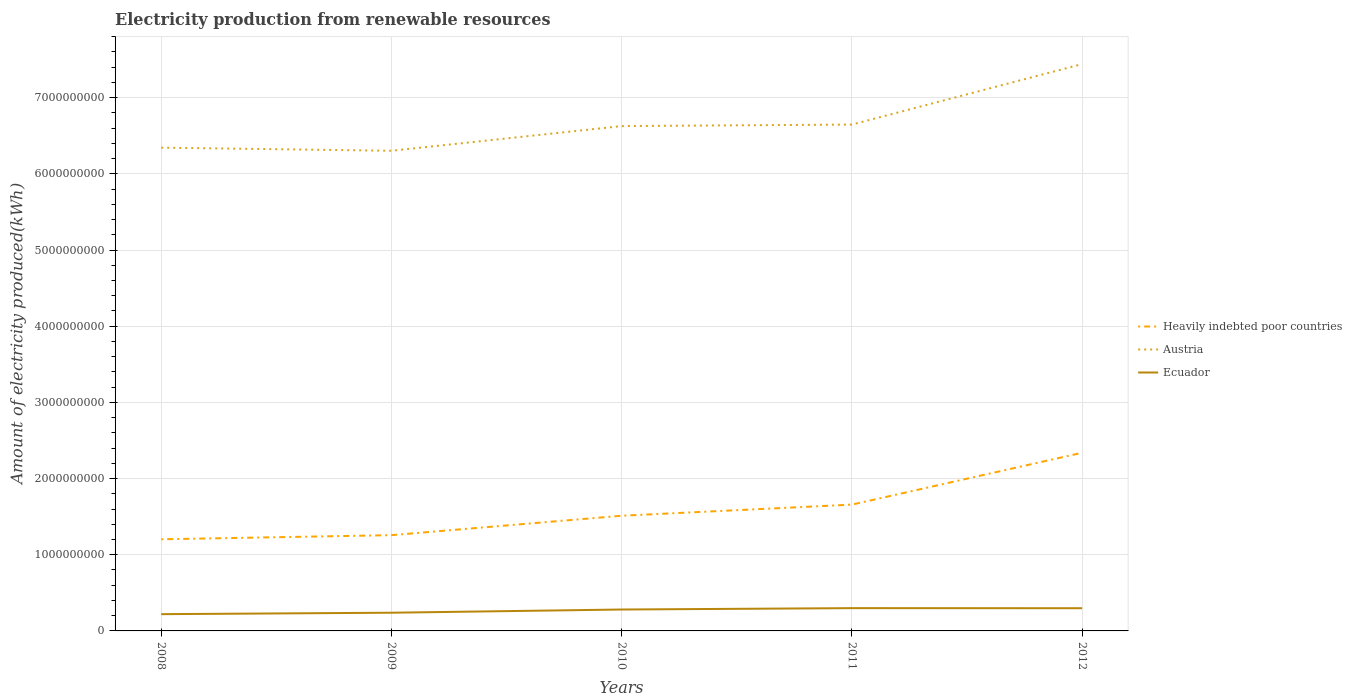How many different coloured lines are there?
Your answer should be compact. 3. Does the line corresponding to Heavily indebted poor countries intersect with the line corresponding to Austria?
Make the answer very short. No. Is the number of lines equal to the number of legend labels?
Your response must be concise. Yes. Across all years, what is the maximum amount of electricity produced in Ecuador?
Your answer should be very brief. 2.20e+08. What is the total amount of electricity produced in Heavily indebted poor countries in the graph?
Give a very brief answer. -5.40e+07. What is the difference between the highest and the second highest amount of electricity produced in Austria?
Provide a succinct answer. 1.14e+09. Is the amount of electricity produced in Ecuador strictly greater than the amount of electricity produced in Austria over the years?
Your answer should be compact. Yes. How many lines are there?
Your answer should be very brief. 3. What is the difference between two consecutive major ticks on the Y-axis?
Your response must be concise. 1.00e+09. Does the graph contain grids?
Make the answer very short. Yes. Where does the legend appear in the graph?
Offer a terse response. Center right. How many legend labels are there?
Give a very brief answer. 3. How are the legend labels stacked?
Give a very brief answer. Vertical. What is the title of the graph?
Keep it short and to the point. Electricity production from renewable resources. What is the label or title of the Y-axis?
Your answer should be very brief. Amount of electricity produced(kWh). What is the Amount of electricity produced(kWh) of Heavily indebted poor countries in 2008?
Your answer should be very brief. 1.20e+09. What is the Amount of electricity produced(kWh) in Austria in 2008?
Ensure brevity in your answer.  6.34e+09. What is the Amount of electricity produced(kWh) in Ecuador in 2008?
Your answer should be compact. 2.20e+08. What is the Amount of electricity produced(kWh) of Heavily indebted poor countries in 2009?
Keep it short and to the point. 1.26e+09. What is the Amount of electricity produced(kWh) of Austria in 2009?
Make the answer very short. 6.30e+09. What is the Amount of electricity produced(kWh) of Ecuador in 2009?
Your answer should be compact. 2.39e+08. What is the Amount of electricity produced(kWh) in Heavily indebted poor countries in 2010?
Ensure brevity in your answer.  1.51e+09. What is the Amount of electricity produced(kWh) of Austria in 2010?
Give a very brief answer. 6.63e+09. What is the Amount of electricity produced(kWh) of Ecuador in 2010?
Keep it short and to the point. 2.81e+08. What is the Amount of electricity produced(kWh) of Heavily indebted poor countries in 2011?
Make the answer very short. 1.66e+09. What is the Amount of electricity produced(kWh) of Austria in 2011?
Your response must be concise. 6.65e+09. What is the Amount of electricity produced(kWh) of Ecuador in 2011?
Your answer should be very brief. 2.99e+08. What is the Amount of electricity produced(kWh) of Heavily indebted poor countries in 2012?
Keep it short and to the point. 2.34e+09. What is the Amount of electricity produced(kWh) in Austria in 2012?
Provide a short and direct response. 7.44e+09. What is the Amount of electricity produced(kWh) in Ecuador in 2012?
Offer a very short reply. 2.98e+08. Across all years, what is the maximum Amount of electricity produced(kWh) of Heavily indebted poor countries?
Offer a very short reply. 2.34e+09. Across all years, what is the maximum Amount of electricity produced(kWh) in Austria?
Provide a short and direct response. 7.44e+09. Across all years, what is the maximum Amount of electricity produced(kWh) in Ecuador?
Your answer should be compact. 2.99e+08. Across all years, what is the minimum Amount of electricity produced(kWh) in Heavily indebted poor countries?
Make the answer very short. 1.20e+09. Across all years, what is the minimum Amount of electricity produced(kWh) in Austria?
Your response must be concise. 6.30e+09. Across all years, what is the minimum Amount of electricity produced(kWh) in Ecuador?
Your answer should be compact. 2.20e+08. What is the total Amount of electricity produced(kWh) in Heavily indebted poor countries in the graph?
Your answer should be compact. 7.97e+09. What is the total Amount of electricity produced(kWh) in Austria in the graph?
Provide a succinct answer. 3.34e+1. What is the total Amount of electricity produced(kWh) in Ecuador in the graph?
Your answer should be compact. 1.34e+09. What is the difference between the Amount of electricity produced(kWh) in Heavily indebted poor countries in 2008 and that in 2009?
Ensure brevity in your answer.  -5.40e+07. What is the difference between the Amount of electricity produced(kWh) in Austria in 2008 and that in 2009?
Your answer should be compact. 4.10e+07. What is the difference between the Amount of electricity produced(kWh) of Ecuador in 2008 and that in 2009?
Keep it short and to the point. -1.90e+07. What is the difference between the Amount of electricity produced(kWh) of Heavily indebted poor countries in 2008 and that in 2010?
Provide a succinct answer. -3.09e+08. What is the difference between the Amount of electricity produced(kWh) in Austria in 2008 and that in 2010?
Offer a terse response. -2.83e+08. What is the difference between the Amount of electricity produced(kWh) in Ecuador in 2008 and that in 2010?
Provide a succinct answer. -6.10e+07. What is the difference between the Amount of electricity produced(kWh) in Heavily indebted poor countries in 2008 and that in 2011?
Offer a very short reply. -4.55e+08. What is the difference between the Amount of electricity produced(kWh) in Austria in 2008 and that in 2011?
Provide a short and direct response. -3.03e+08. What is the difference between the Amount of electricity produced(kWh) in Ecuador in 2008 and that in 2011?
Provide a short and direct response. -7.90e+07. What is the difference between the Amount of electricity produced(kWh) of Heavily indebted poor countries in 2008 and that in 2012?
Keep it short and to the point. -1.14e+09. What is the difference between the Amount of electricity produced(kWh) of Austria in 2008 and that in 2012?
Your answer should be compact. -1.10e+09. What is the difference between the Amount of electricity produced(kWh) in Ecuador in 2008 and that in 2012?
Offer a very short reply. -7.80e+07. What is the difference between the Amount of electricity produced(kWh) of Heavily indebted poor countries in 2009 and that in 2010?
Offer a very short reply. -2.55e+08. What is the difference between the Amount of electricity produced(kWh) of Austria in 2009 and that in 2010?
Your answer should be very brief. -3.24e+08. What is the difference between the Amount of electricity produced(kWh) of Ecuador in 2009 and that in 2010?
Your answer should be compact. -4.20e+07. What is the difference between the Amount of electricity produced(kWh) of Heavily indebted poor countries in 2009 and that in 2011?
Make the answer very short. -4.01e+08. What is the difference between the Amount of electricity produced(kWh) of Austria in 2009 and that in 2011?
Offer a very short reply. -3.44e+08. What is the difference between the Amount of electricity produced(kWh) of Ecuador in 2009 and that in 2011?
Give a very brief answer. -6.00e+07. What is the difference between the Amount of electricity produced(kWh) in Heavily indebted poor countries in 2009 and that in 2012?
Offer a very short reply. -1.08e+09. What is the difference between the Amount of electricity produced(kWh) in Austria in 2009 and that in 2012?
Keep it short and to the point. -1.14e+09. What is the difference between the Amount of electricity produced(kWh) in Ecuador in 2009 and that in 2012?
Give a very brief answer. -5.90e+07. What is the difference between the Amount of electricity produced(kWh) in Heavily indebted poor countries in 2010 and that in 2011?
Offer a terse response. -1.46e+08. What is the difference between the Amount of electricity produced(kWh) of Austria in 2010 and that in 2011?
Provide a short and direct response. -2.00e+07. What is the difference between the Amount of electricity produced(kWh) in Ecuador in 2010 and that in 2011?
Provide a succinct answer. -1.80e+07. What is the difference between the Amount of electricity produced(kWh) in Heavily indebted poor countries in 2010 and that in 2012?
Provide a succinct answer. -8.27e+08. What is the difference between the Amount of electricity produced(kWh) in Austria in 2010 and that in 2012?
Make the answer very short. -8.14e+08. What is the difference between the Amount of electricity produced(kWh) of Ecuador in 2010 and that in 2012?
Your answer should be compact. -1.70e+07. What is the difference between the Amount of electricity produced(kWh) of Heavily indebted poor countries in 2011 and that in 2012?
Provide a short and direct response. -6.81e+08. What is the difference between the Amount of electricity produced(kWh) in Austria in 2011 and that in 2012?
Your answer should be compact. -7.94e+08. What is the difference between the Amount of electricity produced(kWh) in Ecuador in 2011 and that in 2012?
Offer a very short reply. 1.00e+06. What is the difference between the Amount of electricity produced(kWh) in Heavily indebted poor countries in 2008 and the Amount of electricity produced(kWh) in Austria in 2009?
Provide a short and direct response. -5.10e+09. What is the difference between the Amount of electricity produced(kWh) in Heavily indebted poor countries in 2008 and the Amount of electricity produced(kWh) in Ecuador in 2009?
Keep it short and to the point. 9.64e+08. What is the difference between the Amount of electricity produced(kWh) in Austria in 2008 and the Amount of electricity produced(kWh) in Ecuador in 2009?
Make the answer very short. 6.10e+09. What is the difference between the Amount of electricity produced(kWh) in Heavily indebted poor countries in 2008 and the Amount of electricity produced(kWh) in Austria in 2010?
Give a very brief answer. -5.42e+09. What is the difference between the Amount of electricity produced(kWh) of Heavily indebted poor countries in 2008 and the Amount of electricity produced(kWh) of Ecuador in 2010?
Your answer should be compact. 9.22e+08. What is the difference between the Amount of electricity produced(kWh) of Austria in 2008 and the Amount of electricity produced(kWh) of Ecuador in 2010?
Keep it short and to the point. 6.06e+09. What is the difference between the Amount of electricity produced(kWh) of Heavily indebted poor countries in 2008 and the Amount of electricity produced(kWh) of Austria in 2011?
Provide a short and direct response. -5.44e+09. What is the difference between the Amount of electricity produced(kWh) of Heavily indebted poor countries in 2008 and the Amount of electricity produced(kWh) of Ecuador in 2011?
Offer a terse response. 9.04e+08. What is the difference between the Amount of electricity produced(kWh) of Austria in 2008 and the Amount of electricity produced(kWh) of Ecuador in 2011?
Provide a succinct answer. 6.04e+09. What is the difference between the Amount of electricity produced(kWh) in Heavily indebted poor countries in 2008 and the Amount of electricity produced(kWh) in Austria in 2012?
Ensure brevity in your answer.  -6.24e+09. What is the difference between the Amount of electricity produced(kWh) of Heavily indebted poor countries in 2008 and the Amount of electricity produced(kWh) of Ecuador in 2012?
Your answer should be very brief. 9.05e+08. What is the difference between the Amount of electricity produced(kWh) of Austria in 2008 and the Amount of electricity produced(kWh) of Ecuador in 2012?
Your response must be concise. 6.05e+09. What is the difference between the Amount of electricity produced(kWh) of Heavily indebted poor countries in 2009 and the Amount of electricity produced(kWh) of Austria in 2010?
Your answer should be compact. -5.37e+09. What is the difference between the Amount of electricity produced(kWh) of Heavily indebted poor countries in 2009 and the Amount of electricity produced(kWh) of Ecuador in 2010?
Ensure brevity in your answer.  9.76e+08. What is the difference between the Amount of electricity produced(kWh) in Austria in 2009 and the Amount of electricity produced(kWh) in Ecuador in 2010?
Your answer should be very brief. 6.02e+09. What is the difference between the Amount of electricity produced(kWh) of Heavily indebted poor countries in 2009 and the Amount of electricity produced(kWh) of Austria in 2011?
Offer a terse response. -5.39e+09. What is the difference between the Amount of electricity produced(kWh) in Heavily indebted poor countries in 2009 and the Amount of electricity produced(kWh) in Ecuador in 2011?
Make the answer very short. 9.58e+08. What is the difference between the Amount of electricity produced(kWh) of Austria in 2009 and the Amount of electricity produced(kWh) of Ecuador in 2011?
Your answer should be compact. 6.00e+09. What is the difference between the Amount of electricity produced(kWh) of Heavily indebted poor countries in 2009 and the Amount of electricity produced(kWh) of Austria in 2012?
Provide a short and direct response. -6.18e+09. What is the difference between the Amount of electricity produced(kWh) in Heavily indebted poor countries in 2009 and the Amount of electricity produced(kWh) in Ecuador in 2012?
Offer a very short reply. 9.59e+08. What is the difference between the Amount of electricity produced(kWh) of Austria in 2009 and the Amount of electricity produced(kWh) of Ecuador in 2012?
Provide a short and direct response. 6.00e+09. What is the difference between the Amount of electricity produced(kWh) of Heavily indebted poor countries in 2010 and the Amount of electricity produced(kWh) of Austria in 2011?
Give a very brief answer. -5.14e+09. What is the difference between the Amount of electricity produced(kWh) of Heavily indebted poor countries in 2010 and the Amount of electricity produced(kWh) of Ecuador in 2011?
Your answer should be very brief. 1.21e+09. What is the difference between the Amount of electricity produced(kWh) of Austria in 2010 and the Amount of electricity produced(kWh) of Ecuador in 2011?
Ensure brevity in your answer.  6.33e+09. What is the difference between the Amount of electricity produced(kWh) of Heavily indebted poor countries in 2010 and the Amount of electricity produced(kWh) of Austria in 2012?
Your answer should be very brief. -5.93e+09. What is the difference between the Amount of electricity produced(kWh) in Heavily indebted poor countries in 2010 and the Amount of electricity produced(kWh) in Ecuador in 2012?
Give a very brief answer. 1.21e+09. What is the difference between the Amount of electricity produced(kWh) in Austria in 2010 and the Amount of electricity produced(kWh) in Ecuador in 2012?
Offer a very short reply. 6.33e+09. What is the difference between the Amount of electricity produced(kWh) in Heavily indebted poor countries in 2011 and the Amount of electricity produced(kWh) in Austria in 2012?
Your answer should be very brief. -5.78e+09. What is the difference between the Amount of electricity produced(kWh) of Heavily indebted poor countries in 2011 and the Amount of electricity produced(kWh) of Ecuador in 2012?
Provide a succinct answer. 1.36e+09. What is the difference between the Amount of electricity produced(kWh) in Austria in 2011 and the Amount of electricity produced(kWh) in Ecuador in 2012?
Your response must be concise. 6.35e+09. What is the average Amount of electricity produced(kWh) of Heavily indebted poor countries per year?
Offer a terse response. 1.59e+09. What is the average Amount of electricity produced(kWh) of Austria per year?
Offer a terse response. 6.67e+09. What is the average Amount of electricity produced(kWh) in Ecuador per year?
Your answer should be compact. 2.67e+08. In the year 2008, what is the difference between the Amount of electricity produced(kWh) in Heavily indebted poor countries and Amount of electricity produced(kWh) in Austria?
Provide a short and direct response. -5.14e+09. In the year 2008, what is the difference between the Amount of electricity produced(kWh) in Heavily indebted poor countries and Amount of electricity produced(kWh) in Ecuador?
Offer a very short reply. 9.83e+08. In the year 2008, what is the difference between the Amount of electricity produced(kWh) of Austria and Amount of electricity produced(kWh) of Ecuador?
Ensure brevity in your answer.  6.12e+09. In the year 2009, what is the difference between the Amount of electricity produced(kWh) in Heavily indebted poor countries and Amount of electricity produced(kWh) in Austria?
Offer a terse response. -5.05e+09. In the year 2009, what is the difference between the Amount of electricity produced(kWh) in Heavily indebted poor countries and Amount of electricity produced(kWh) in Ecuador?
Keep it short and to the point. 1.02e+09. In the year 2009, what is the difference between the Amount of electricity produced(kWh) of Austria and Amount of electricity produced(kWh) of Ecuador?
Ensure brevity in your answer.  6.06e+09. In the year 2010, what is the difference between the Amount of electricity produced(kWh) in Heavily indebted poor countries and Amount of electricity produced(kWh) in Austria?
Provide a succinct answer. -5.12e+09. In the year 2010, what is the difference between the Amount of electricity produced(kWh) of Heavily indebted poor countries and Amount of electricity produced(kWh) of Ecuador?
Provide a short and direct response. 1.23e+09. In the year 2010, what is the difference between the Amount of electricity produced(kWh) of Austria and Amount of electricity produced(kWh) of Ecuador?
Give a very brief answer. 6.35e+09. In the year 2011, what is the difference between the Amount of electricity produced(kWh) of Heavily indebted poor countries and Amount of electricity produced(kWh) of Austria?
Ensure brevity in your answer.  -4.99e+09. In the year 2011, what is the difference between the Amount of electricity produced(kWh) of Heavily indebted poor countries and Amount of electricity produced(kWh) of Ecuador?
Make the answer very short. 1.36e+09. In the year 2011, what is the difference between the Amount of electricity produced(kWh) of Austria and Amount of electricity produced(kWh) of Ecuador?
Provide a short and direct response. 6.35e+09. In the year 2012, what is the difference between the Amount of electricity produced(kWh) of Heavily indebted poor countries and Amount of electricity produced(kWh) of Austria?
Make the answer very short. -5.10e+09. In the year 2012, what is the difference between the Amount of electricity produced(kWh) of Heavily indebted poor countries and Amount of electricity produced(kWh) of Ecuador?
Give a very brief answer. 2.04e+09. In the year 2012, what is the difference between the Amount of electricity produced(kWh) of Austria and Amount of electricity produced(kWh) of Ecuador?
Your response must be concise. 7.14e+09. What is the ratio of the Amount of electricity produced(kWh) of Heavily indebted poor countries in 2008 to that in 2009?
Your response must be concise. 0.96. What is the ratio of the Amount of electricity produced(kWh) of Ecuador in 2008 to that in 2009?
Keep it short and to the point. 0.92. What is the ratio of the Amount of electricity produced(kWh) of Heavily indebted poor countries in 2008 to that in 2010?
Offer a very short reply. 0.8. What is the ratio of the Amount of electricity produced(kWh) in Austria in 2008 to that in 2010?
Your answer should be very brief. 0.96. What is the ratio of the Amount of electricity produced(kWh) in Ecuador in 2008 to that in 2010?
Ensure brevity in your answer.  0.78. What is the ratio of the Amount of electricity produced(kWh) of Heavily indebted poor countries in 2008 to that in 2011?
Make the answer very short. 0.73. What is the ratio of the Amount of electricity produced(kWh) of Austria in 2008 to that in 2011?
Your answer should be very brief. 0.95. What is the ratio of the Amount of electricity produced(kWh) in Ecuador in 2008 to that in 2011?
Provide a short and direct response. 0.74. What is the ratio of the Amount of electricity produced(kWh) in Heavily indebted poor countries in 2008 to that in 2012?
Ensure brevity in your answer.  0.51. What is the ratio of the Amount of electricity produced(kWh) in Austria in 2008 to that in 2012?
Offer a very short reply. 0.85. What is the ratio of the Amount of electricity produced(kWh) in Ecuador in 2008 to that in 2012?
Your answer should be very brief. 0.74. What is the ratio of the Amount of electricity produced(kWh) of Heavily indebted poor countries in 2009 to that in 2010?
Make the answer very short. 0.83. What is the ratio of the Amount of electricity produced(kWh) in Austria in 2009 to that in 2010?
Keep it short and to the point. 0.95. What is the ratio of the Amount of electricity produced(kWh) of Ecuador in 2009 to that in 2010?
Your answer should be compact. 0.85. What is the ratio of the Amount of electricity produced(kWh) in Heavily indebted poor countries in 2009 to that in 2011?
Your answer should be very brief. 0.76. What is the ratio of the Amount of electricity produced(kWh) of Austria in 2009 to that in 2011?
Offer a very short reply. 0.95. What is the ratio of the Amount of electricity produced(kWh) of Ecuador in 2009 to that in 2011?
Your answer should be very brief. 0.8. What is the ratio of the Amount of electricity produced(kWh) of Heavily indebted poor countries in 2009 to that in 2012?
Give a very brief answer. 0.54. What is the ratio of the Amount of electricity produced(kWh) in Austria in 2009 to that in 2012?
Provide a short and direct response. 0.85. What is the ratio of the Amount of electricity produced(kWh) of Ecuador in 2009 to that in 2012?
Provide a short and direct response. 0.8. What is the ratio of the Amount of electricity produced(kWh) in Heavily indebted poor countries in 2010 to that in 2011?
Offer a very short reply. 0.91. What is the ratio of the Amount of electricity produced(kWh) of Ecuador in 2010 to that in 2011?
Provide a short and direct response. 0.94. What is the ratio of the Amount of electricity produced(kWh) in Heavily indebted poor countries in 2010 to that in 2012?
Your answer should be very brief. 0.65. What is the ratio of the Amount of electricity produced(kWh) of Austria in 2010 to that in 2012?
Give a very brief answer. 0.89. What is the ratio of the Amount of electricity produced(kWh) in Ecuador in 2010 to that in 2012?
Make the answer very short. 0.94. What is the ratio of the Amount of electricity produced(kWh) of Heavily indebted poor countries in 2011 to that in 2012?
Your response must be concise. 0.71. What is the ratio of the Amount of electricity produced(kWh) in Austria in 2011 to that in 2012?
Your answer should be compact. 0.89. What is the ratio of the Amount of electricity produced(kWh) in Ecuador in 2011 to that in 2012?
Your answer should be very brief. 1. What is the difference between the highest and the second highest Amount of electricity produced(kWh) in Heavily indebted poor countries?
Ensure brevity in your answer.  6.81e+08. What is the difference between the highest and the second highest Amount of electricity produced(kWh) of Austria?
Your response must be concise. 7.94e+08. What is the difference between the highest and the second highest Amount of electricity produced(kWh) of Ecuador?
Your answer should be very brief. 1.00e+06. What is the difference between the highest and the lowest Amount of electricity produced(kWh) of Heavily indebted poor countries?
Provide a succinct answer. 1.14e+09. What is the difference between the highest and the lowest Amount of electricity produced(kWh) in Austria?
Your answer should be very brief. 1.14e+09. What is the difference between the highest and the lowest Amount of electricity produced(kWh) in Ecuador?
Provide a succinct answer. 7.90e+07. 